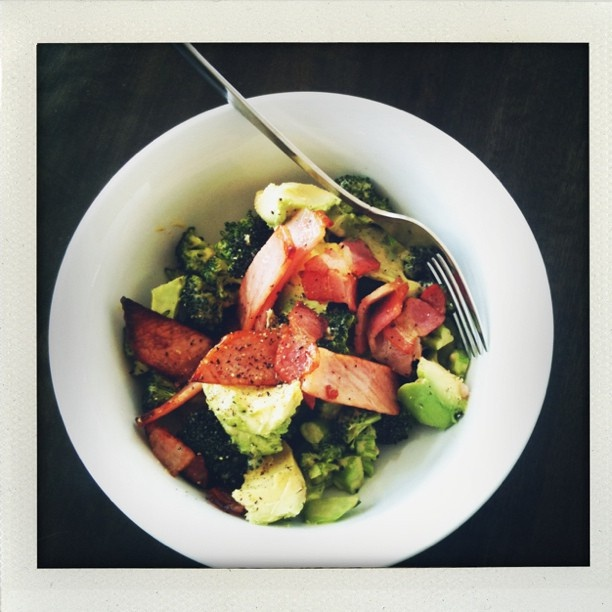Describe the objects in this image and their specific colors. I can see bowl in lightgray, black, beige, and olive tones, fork in lightgray, black, darkgreen, and gray tones, broccoli in lightgray, black, darkgreen, and olive tones, broccoli in lightgray, black, maroon, brown, and gray tones, and broccoli in lightgray, black, darkgreen, and olive tones in this image. 